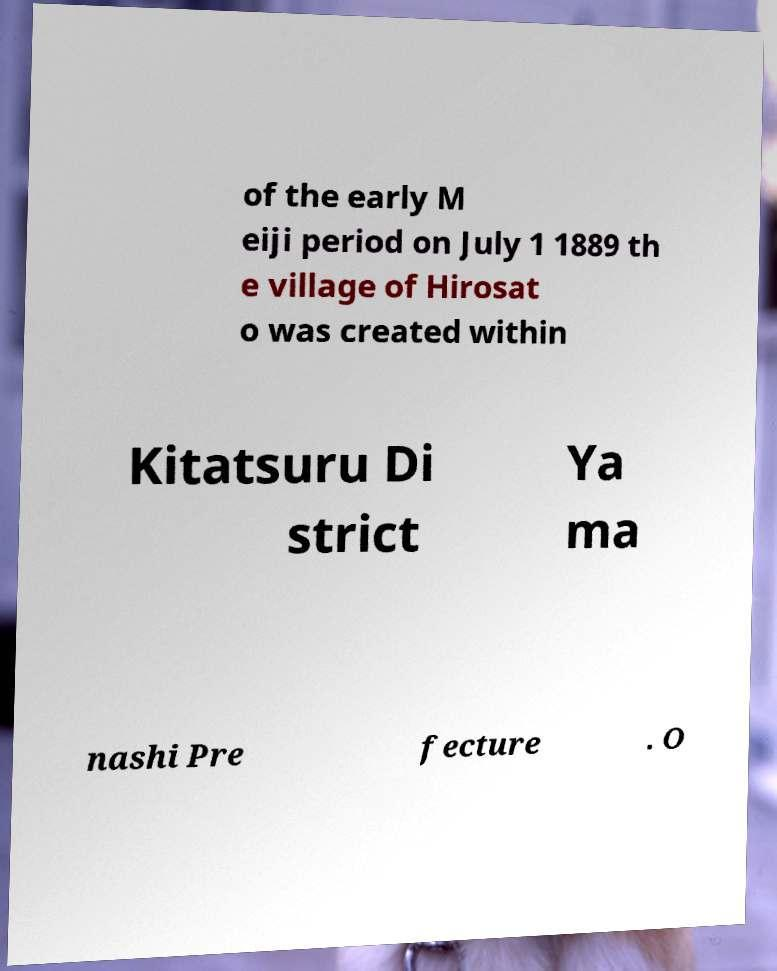What messages or text are displayed in this image? I need them in a readable, typed format. of the early M eiji period on July 1 1889 th e village of Hirosat o was created within Kitatsuru Di strict Ya ma nashi Pre fecture . O 